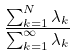<formula> <loc_0><loc_0><loc_500><loc_500>\frac { \sum _ { k = 1 } ^ { N } \lambda _ { k } } { \sum _ { k = 1 } ^ { \infty } \lambda _ { k } }</formula> 